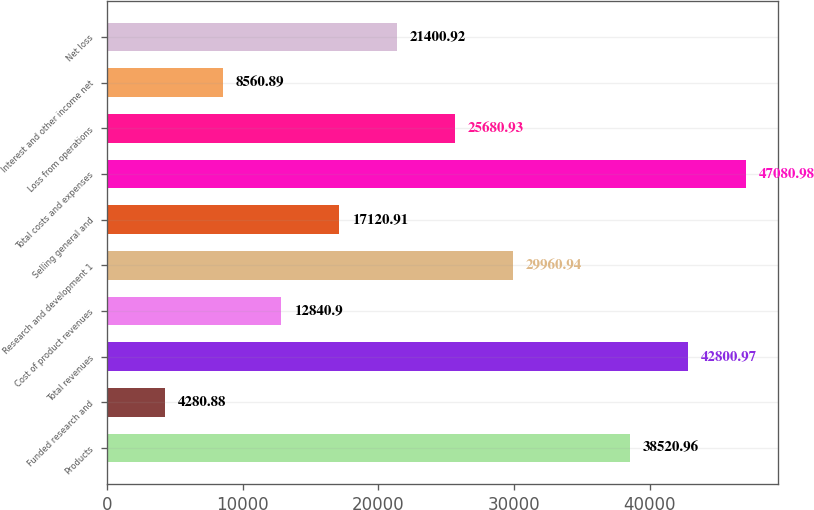<chart> <loc_0><loc_0><loc_500><loc_500><bar_chart><fcel>Products<fcel>Funded research and<fcel>Total revenues<fcel>Cost of product revenues<fcel>Research and development 1<fcel>Selling general and<fcel>Total costs and expenses<fcel>Loss from operations<fcel>Interest and other income net<fcel>Net loss<nl><fcel>38521<fcel>4280.88<fcel>42801<fcel>12840.9<fcel>29960.9<fcel>17120.9<fcel>47081<fcel>25680.9<fcel>8560.89<fcel>21400.9<nl></chart> 